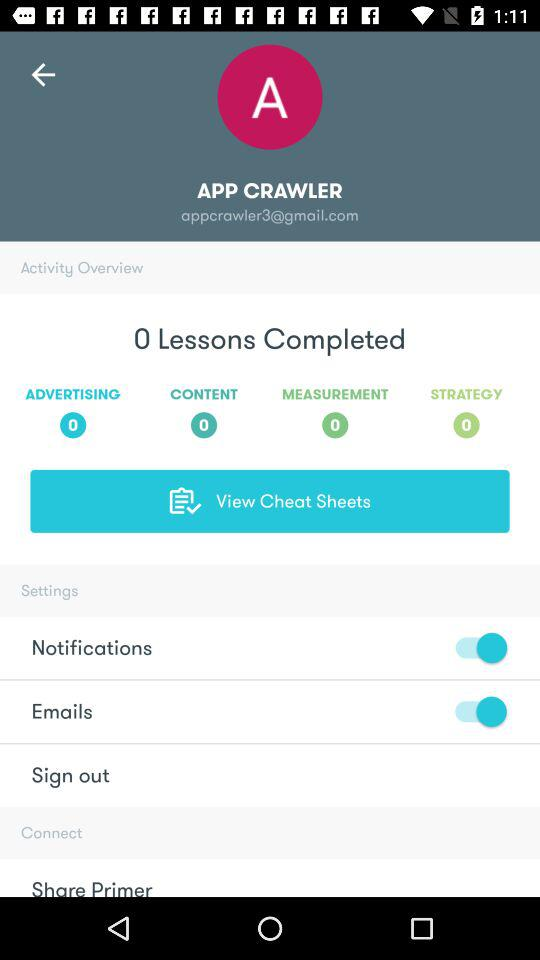What is the user name? The user name is "APP CRAWLER". 